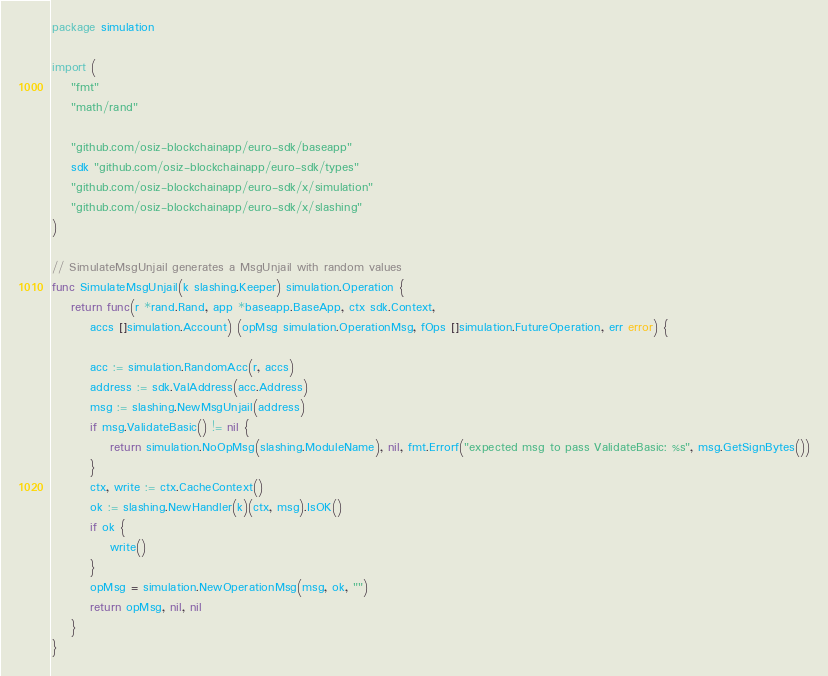Convert code to text. <code><loc_0><loc_0><loc_500><loc_500><_Go_>package simulation

import (
	"fmt"
	"math/rand"

	"github.com/osiz-blockchainapp/euro-sdk/baseapp"
	sdk "github.com/osiz-blockchainapp/euro-sdk/types"
	"github.com/osiz-blockchainapp/euro-sdk/x/simulation"
	"github.com/osiz-blockchainapp/euro-sdk/x/slashing"
)

// SimulateMsgUnjail generates a MsgUnjail with random values
func SimulateMsgUnjail(k slashing.Keeper) simulation.Operation {
	return func(r *rand.Rand, app *baseapp.BaseApp, ctx sdk.Context,
		accs []simulation.Account) (opMsg simulation.OperationMsg, fOps []simulation.FutureOperation, err error) {

		acc := simulation.RandomAcc(r, accs)
		address := sdk.ValAddress(acc.Address)
		msg := slashing.NewMsgUnjail(address)
		if msg.ValidateBasic() != nil {
			return simulation.NoOpMsg(slashing.ModuleName), nil, fmt.Errorf("expected msg to pass ValidateBasic: %s", msg.GetSignBytes())
		}
		ctx, write := ctx.CacheContext()
		ok := slashing.NewHandler(k)(ctx, msg).IsOK()
		if ok {
			write()
		}
		opMsg = simulation.NewOperationMsg(msg, ok, "")
		return opMsg, nil, nil
	}
}
</code> 